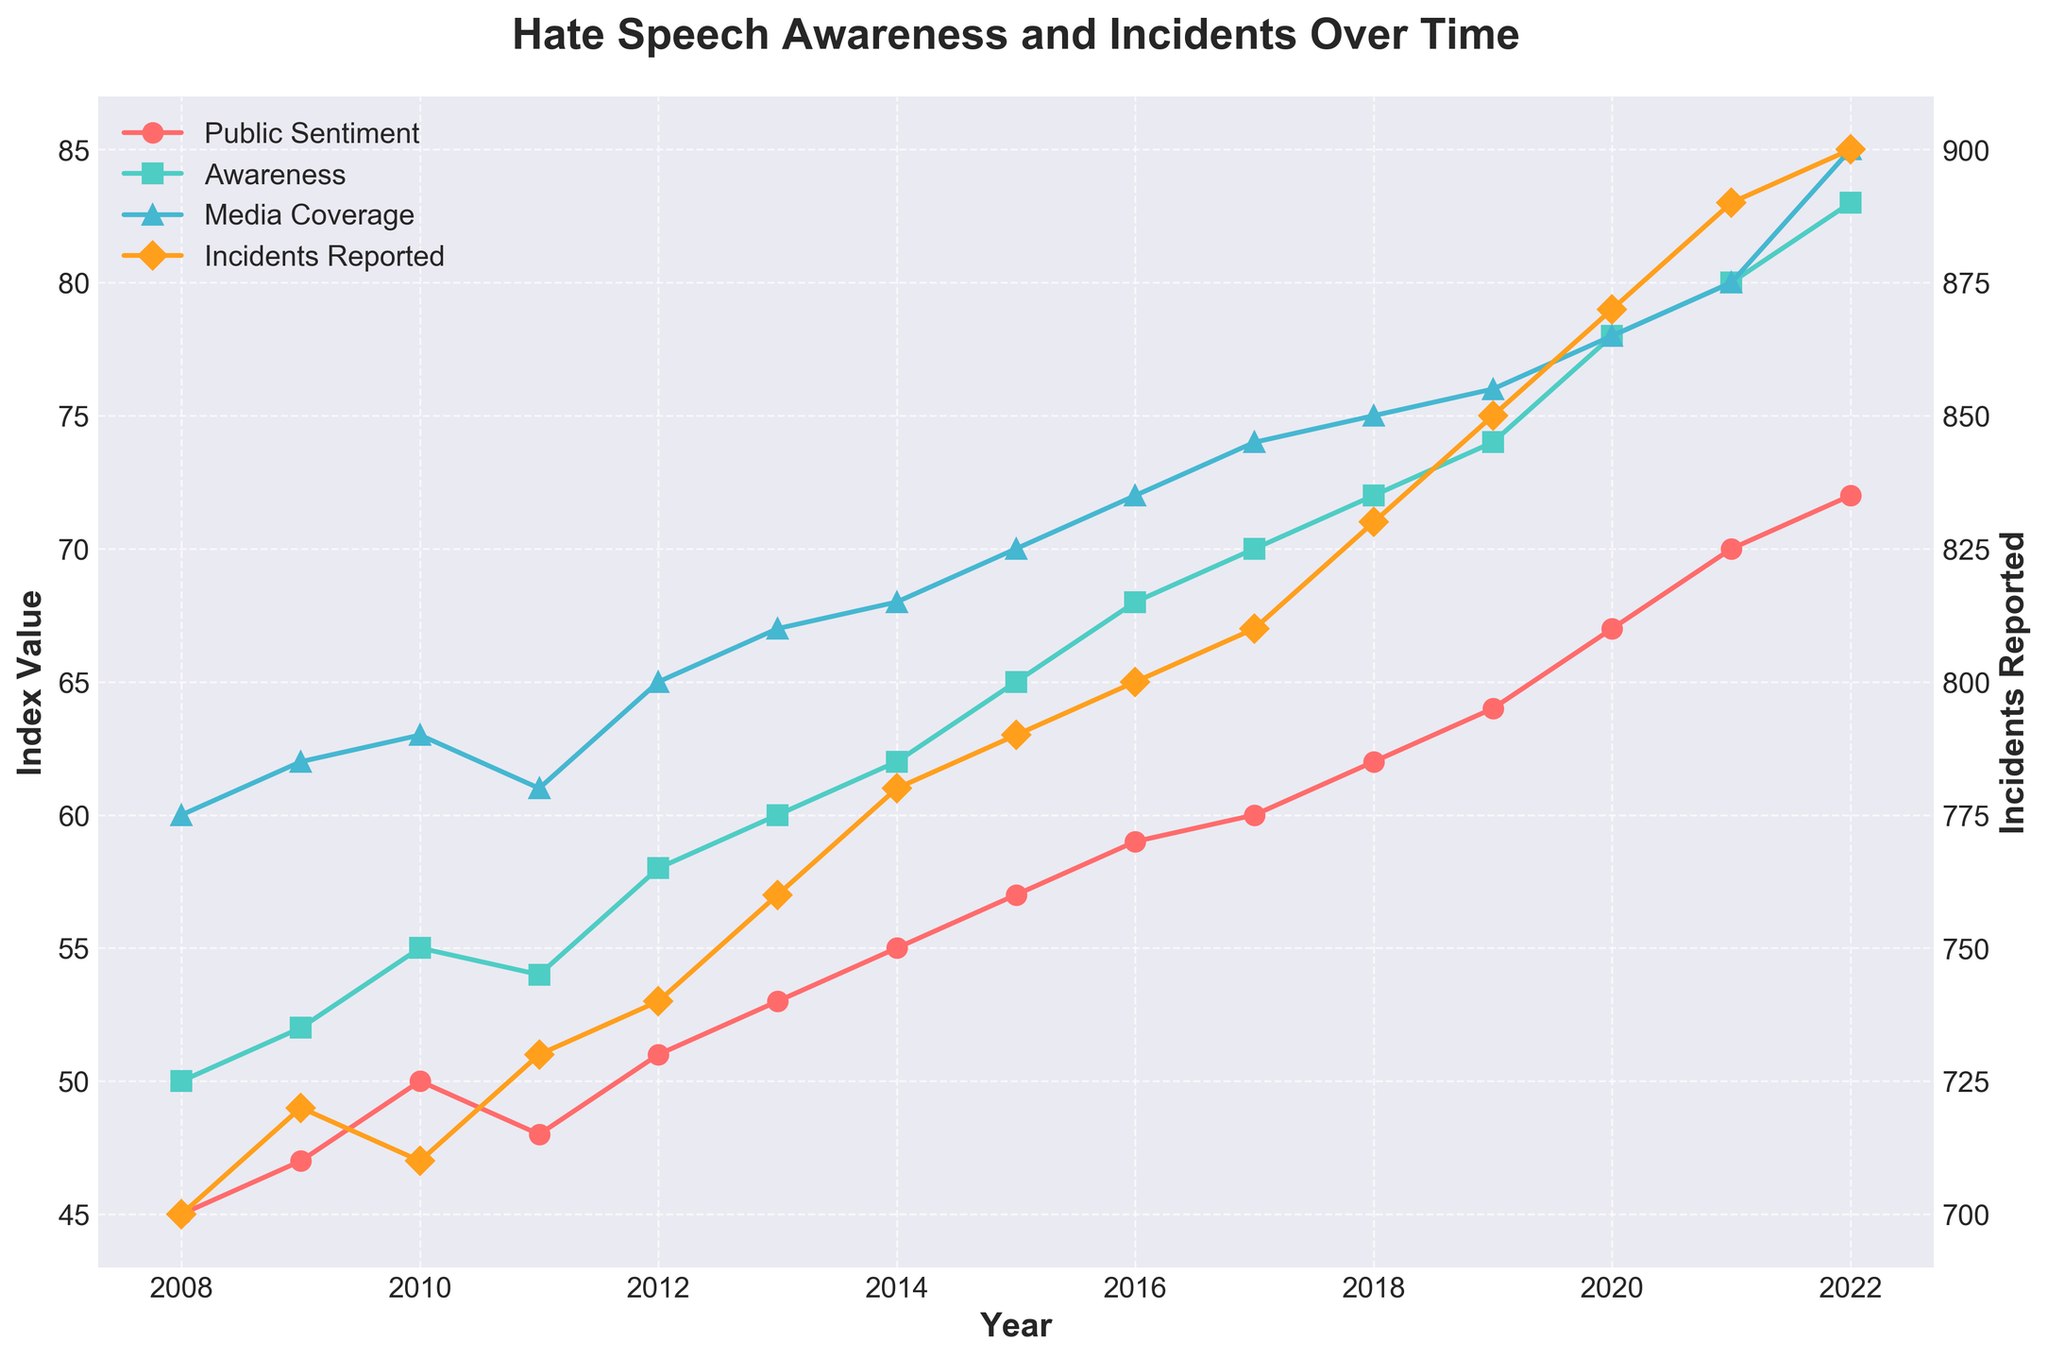What is the title of the figure? The title can usually be found at the top of a plot, indicating the subject of the visualization. Here, the title is directly above the plot.
Answer: Hate Speech Awareness and Incidents Over Time How many indices are plotted over time in the figure? By carefully examining the legend and the plot, we can see four different lines, each representing a different index: Public Sentiment, Awareness, Media Coverage, and Incidents Reported.
Answer: Four In what year did the Public Sentiment Index reach 60? By locating the "Public Sentiment Index" line on the plot and following it, it intersects with the value 60 around the year label on the horizontal axis.
Answer: 2017 How does the Media Coverage Index in 2022 compare to its value in 2021? By finding the blue upward-pointing triangle line for Media Coverage Index at the years 2021 and 2022, we can see the value increased from 80 in 2021 to 85 in 2022.
Answer: Increased What year had the highest number of reported incidents? To determine this, we look for the peak of the orange diamond line (Incidents Reported Index) and note the corresponding year on the horizontal axis.
Answer: 2022 What is the difference between the Awareness Index and the Public Sentiment Index in 2020? Find both the green square and the red circle points on the plot for the year 2020. Subtract the Public Sentiment Index (67) from the Awareness Index (78).
Answer: 11 Which index showed the largest increase from 2008 to 2022? To find this, calculate the change for each index between 2008 and 2022: Public Sentiment (72-45=27), Awareness (83-50=33), Media Coverage (85-60=25), Incidents Reported (900-700=200). The largest increase is in Incidents Reported.
Answer: Incidents Reported Index Did the Public Sentiment and Awareness Index move in the same direction every year? Check if each pair of consecutive points on both the red circle line and the green square line always move up or down together.
Answer: Yes What patterns can you observe in the relationship between the Media Coverage Index and reported incidents over time? By analyzing both the blue upward-pointing triangle line and the orange diamond line, we can notice that as Media Coverage tends to increase, so does the number of incidents reported.
Answer: Positive correlation What was the lowest Awareness Index value and in which year? Locate the lowest point on the green square line and note the corresponding value and year. The lowest value is in 2008, with a value of 50.
Answer: 50 in 2008 